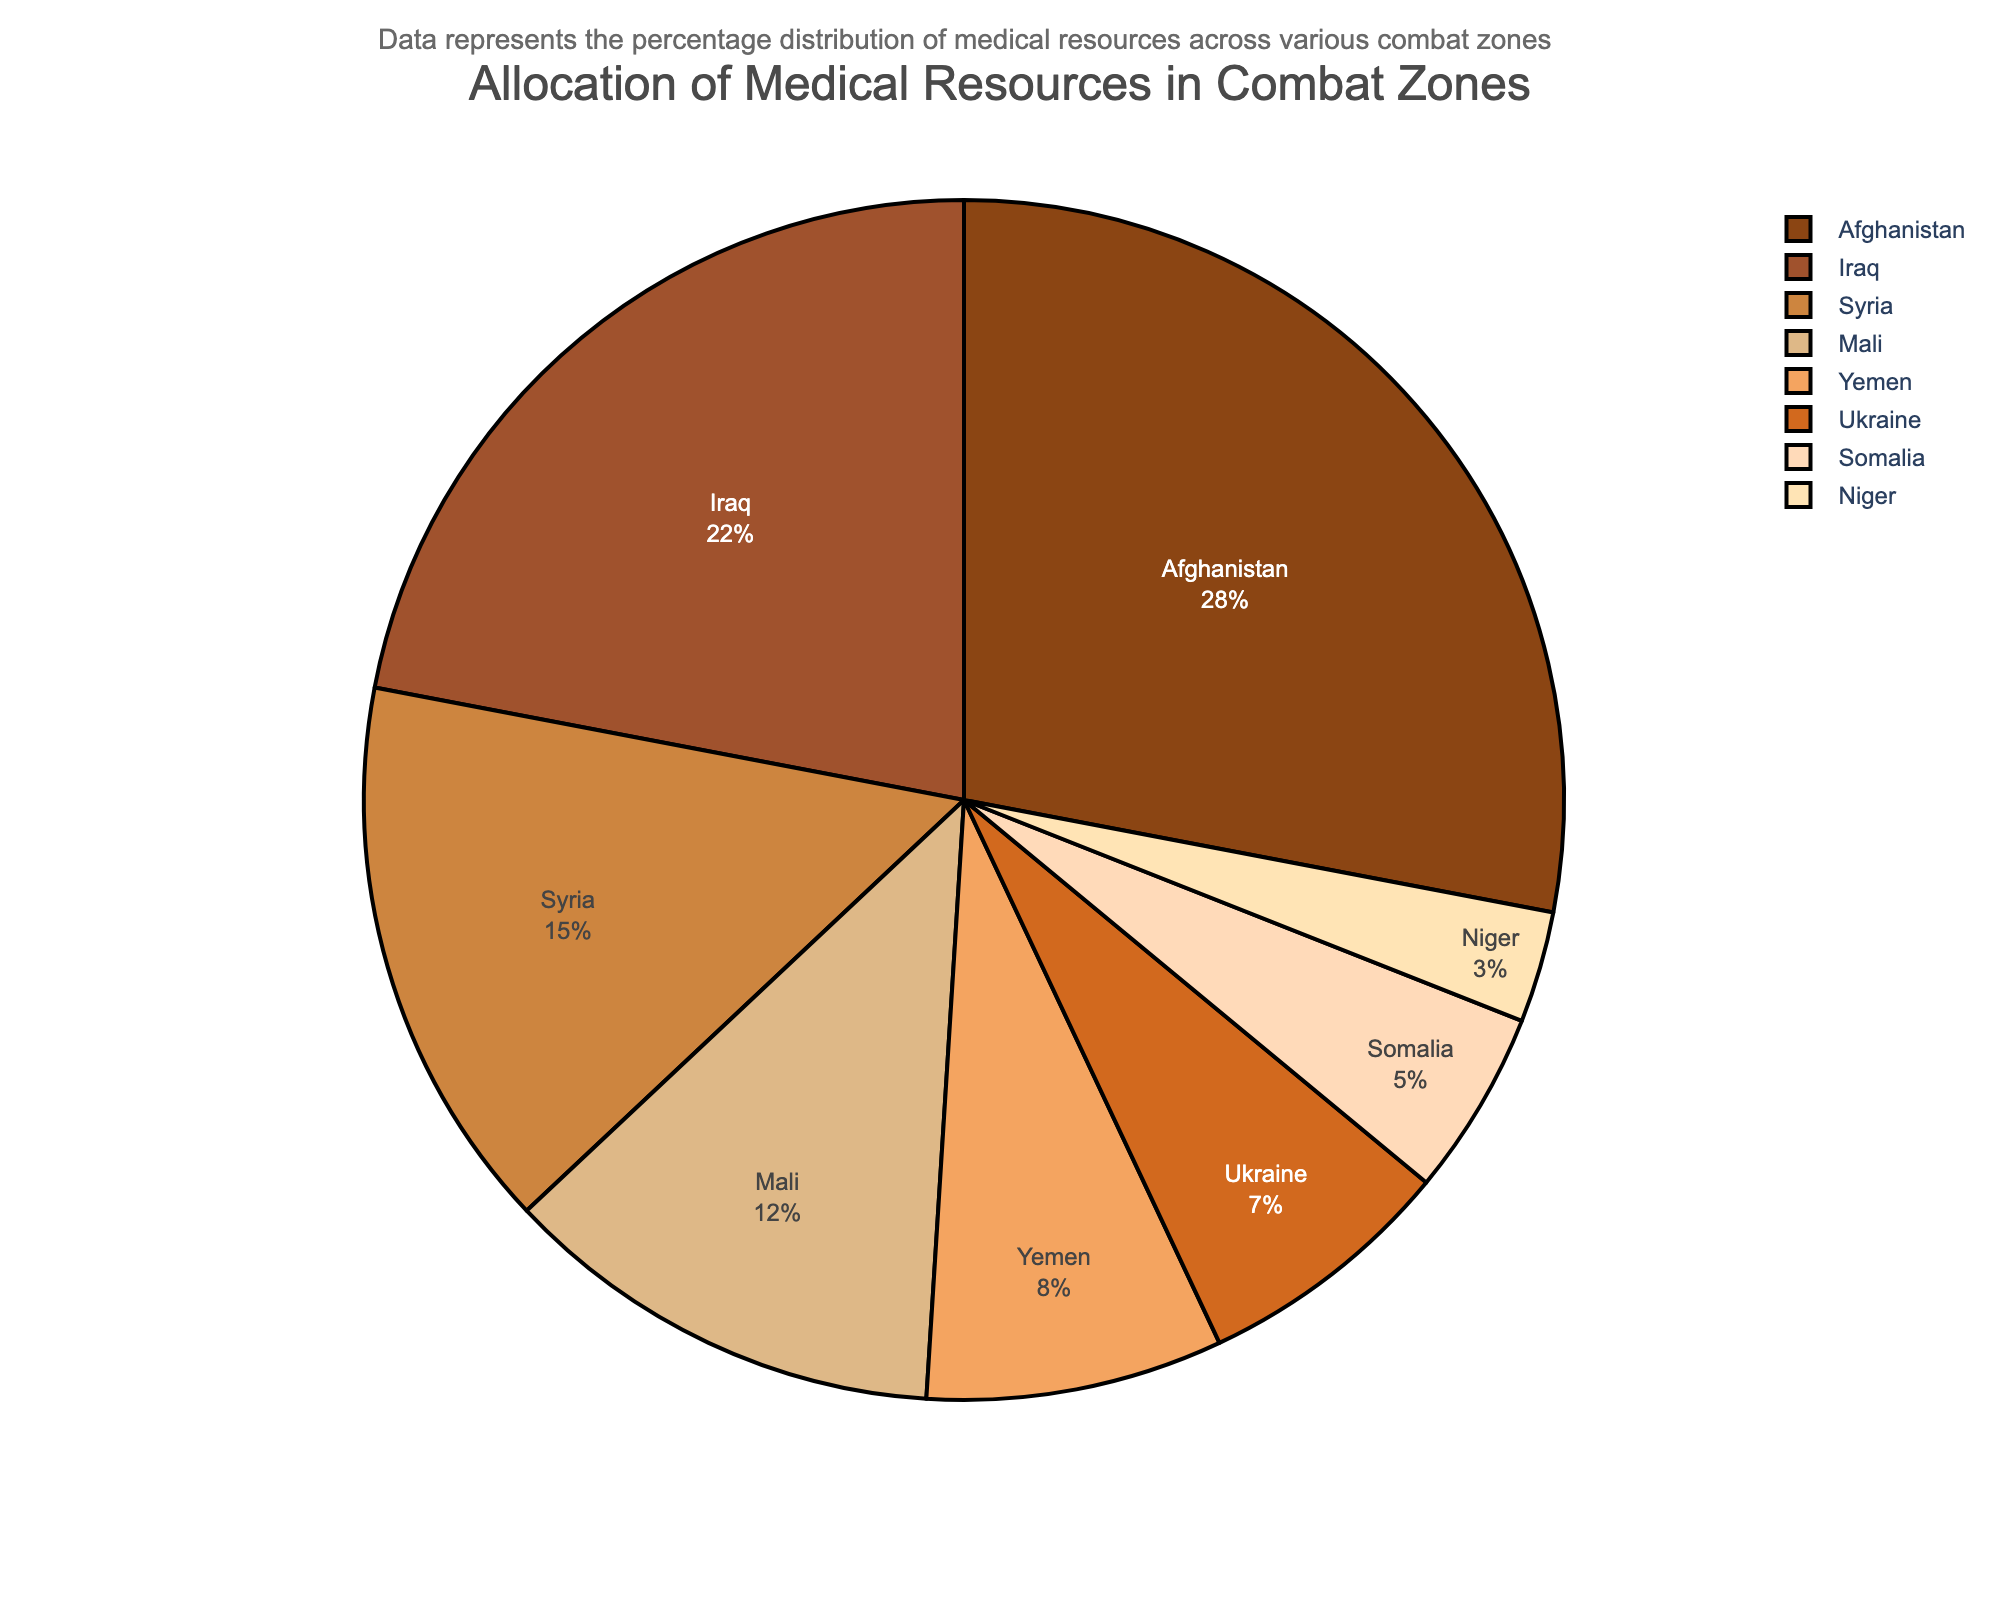What percentage of medical resources is allocated to Somalia? Look at the slice representing Somalia and read the percentage value listed.
Answer: 5% Which combat zone receives the highest allocation of medical resources? Identify the largest slice in the pie chart. The label indicates that Afghanistan has the highest allocation.
Answer: Afghanistan What is the combined percentage of medical resources allocated to Yemen and Ukraine? Sum the percentages for Yemen and Ukraine: 8% (Yemen) + 7% (Ukraine) = 15%.
Answer: 15% Is more medical resources allocated to Iraq or Syria? Compare the sizes of the slices for Iraq and Syria. The percentages indicate Iraq gets 22% and Syria gets 15%.
Answer: Iraq Which two combat zones have the smallest allocation of medical resources, and what is their combined percentage? Identify the two smallest slices, which are Niger (3%) and Somalia (5%). Their combined percentage is 3% + 5% = 8%.
Answer: Niger and Somalia, 8% How much higher is the allocation of medical resources in Afghanistan compared to Mali? Subtract Mali’s percentage from Afghanistan’s: 28% (Afghanistan) - 12% (Mali) = 16%.
Answer: 16% Which combat zones have a higher allocation than Yemen? Find all combat zones with percentages greater than Yemen's 8%. These are Afghanistan (28%), Iraq (22%), Syria (15%), Mali (12%).
Answer: Afghanistan, Iraq, Syria, Mali What is the range of percentages allocated across all combat zones? Identify the highest and lowest percentages: 28% (highest, Afghanistan) - 3% (lowest, Niger) = 25%.
Answer: 25% What is the difference in resource allocation between the zones with the highest and the second-highest percentages? Subtract the percentage of Iraq (22%) from Afghanistan (28%): 28% - 22% = 6%.
Answer: 6% What percentage of medical resources is allocated to the combat zones in Africa (Mali, Somalia, Niger)? Sum the percentages for Mali (12%), Somalia (5%), and Niger (3%): 12% + 5% + 3% = 20%.
Answer: 20% 